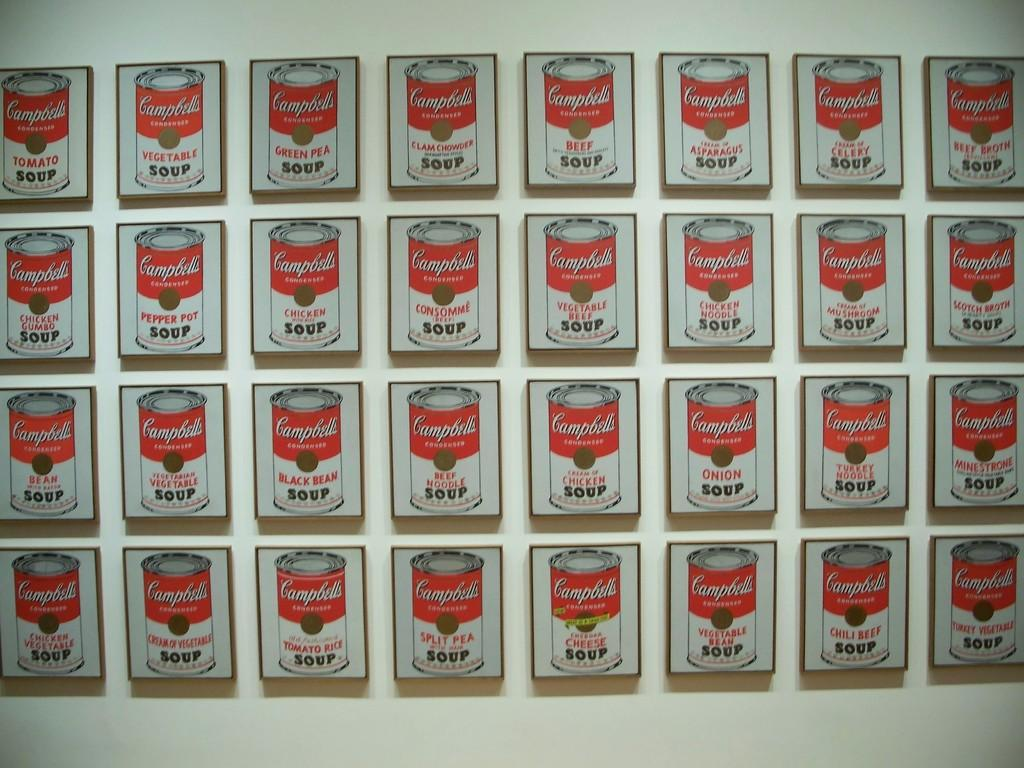What objects are present in the image that contain photos? There are photo frames in the image. What is inside the photo frames? The photo frames contain a tin. What can be read on the tin? There is text on the tin. Where is the tin located in the image? The tin is on the wall. What type of shoes are hanging on the wall next to the tin? There are no shoes present in the image; it only features photo frames, a tin, and text. 